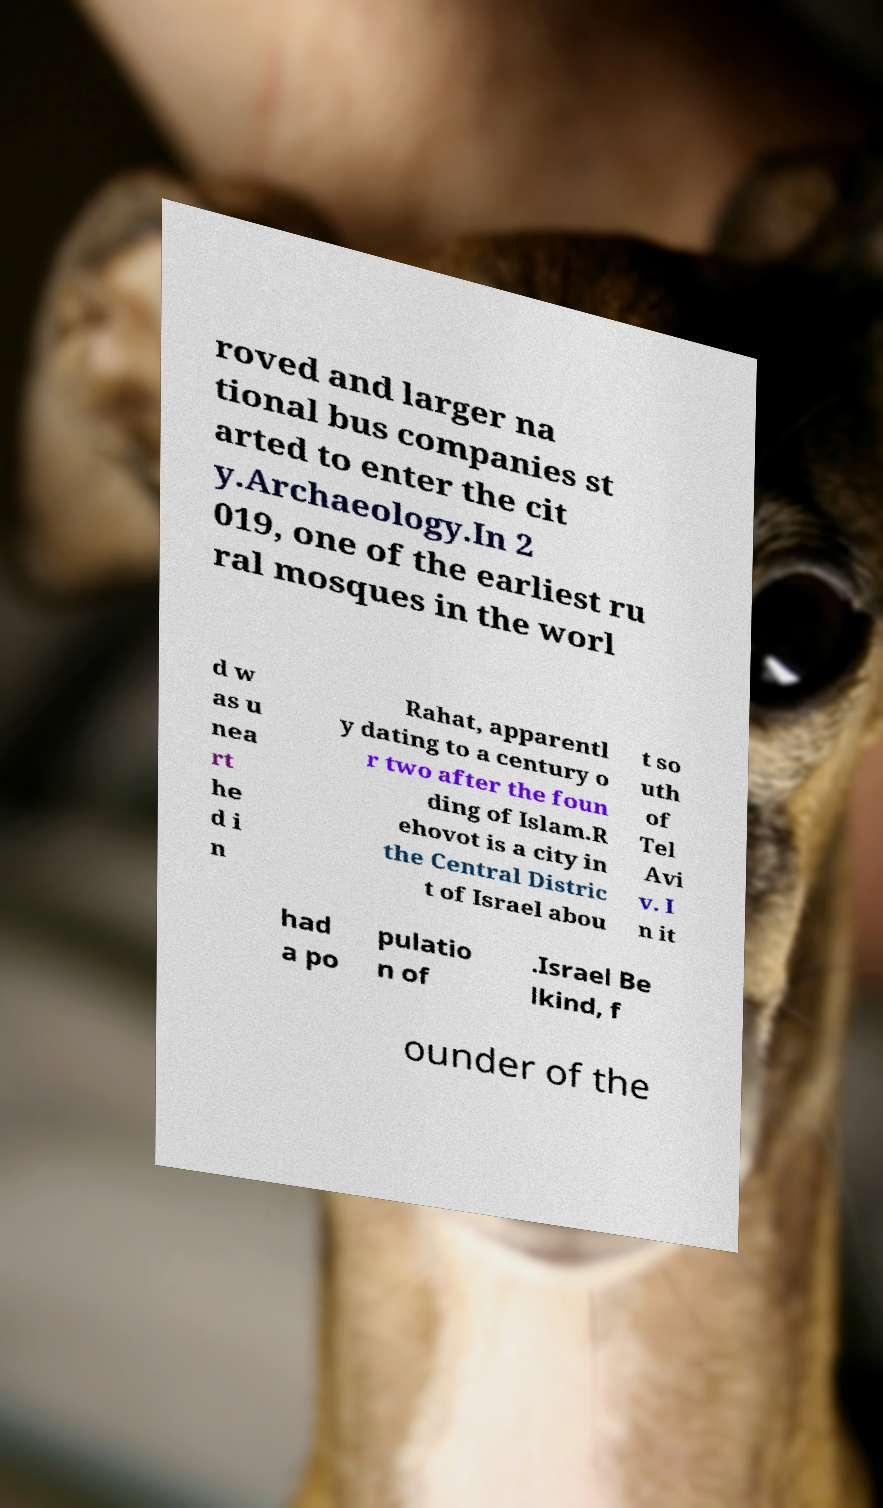There's text embedded in this image that I need extracted. Can you transcribe it verbatim? roved and larger na tional bus companies st arted to enter the cit y.Archaeology.In 2 019, one of the earliest ru ral mosques in the worl d w as u nea rt he d i n Rahat, apparentl y dating to a century o r two after the foun ding of Islam.R ehovot is a city in the Central Distric t of Israel abou t so uth of Tel Avi v. I n it had a po pulatio n of .Israel Be lkind, f ounder of the 